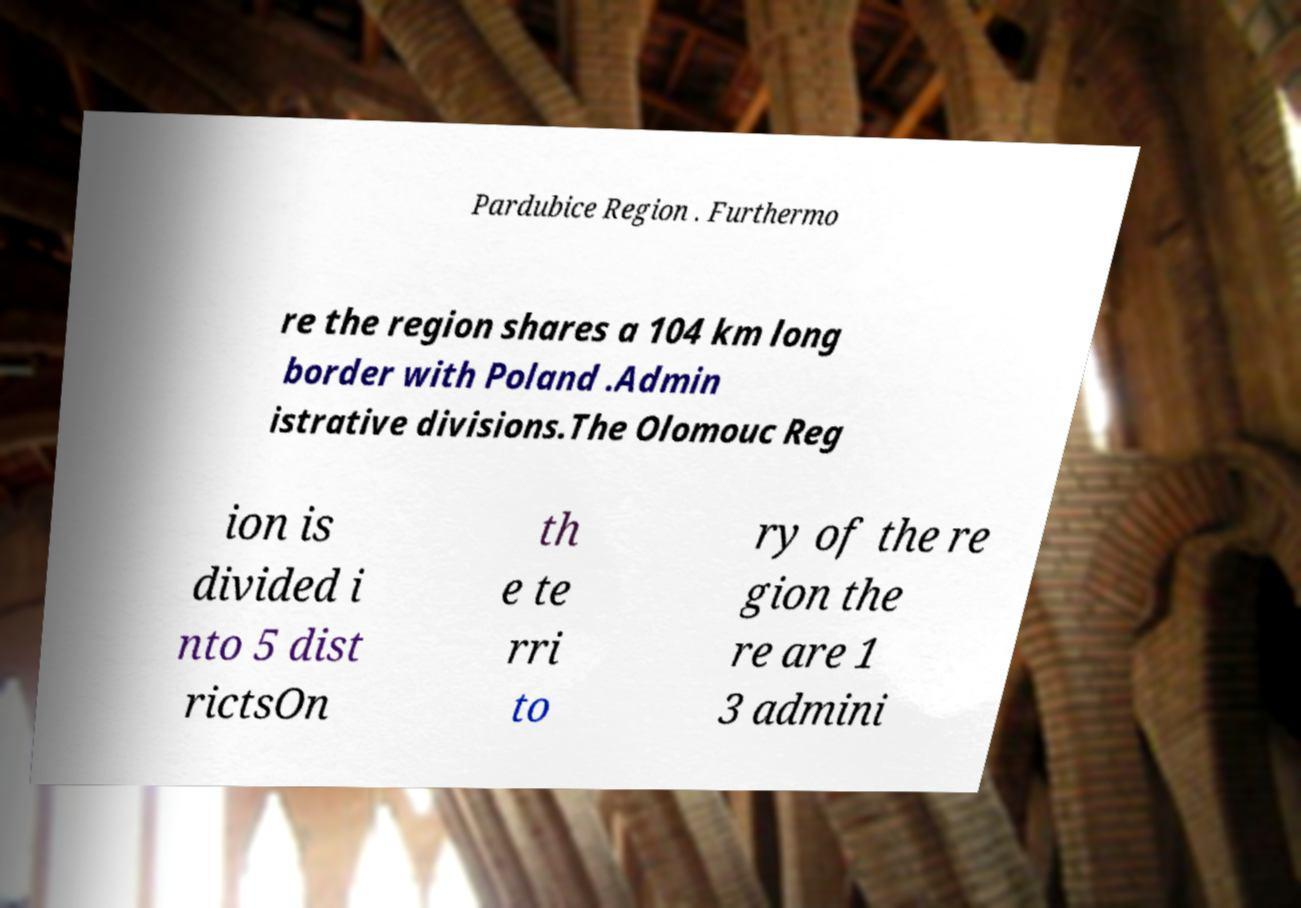Please read and relay the text visible in this image. What does it say? Pardubice Region . Furthermo re the region shares a 104 km long border with Poland .Admin istrative divisions.The Olomouc Reg ion is divided i nto 5 dist rictsOn th e te rri to ry of the re gion the re are 1 3 admini 